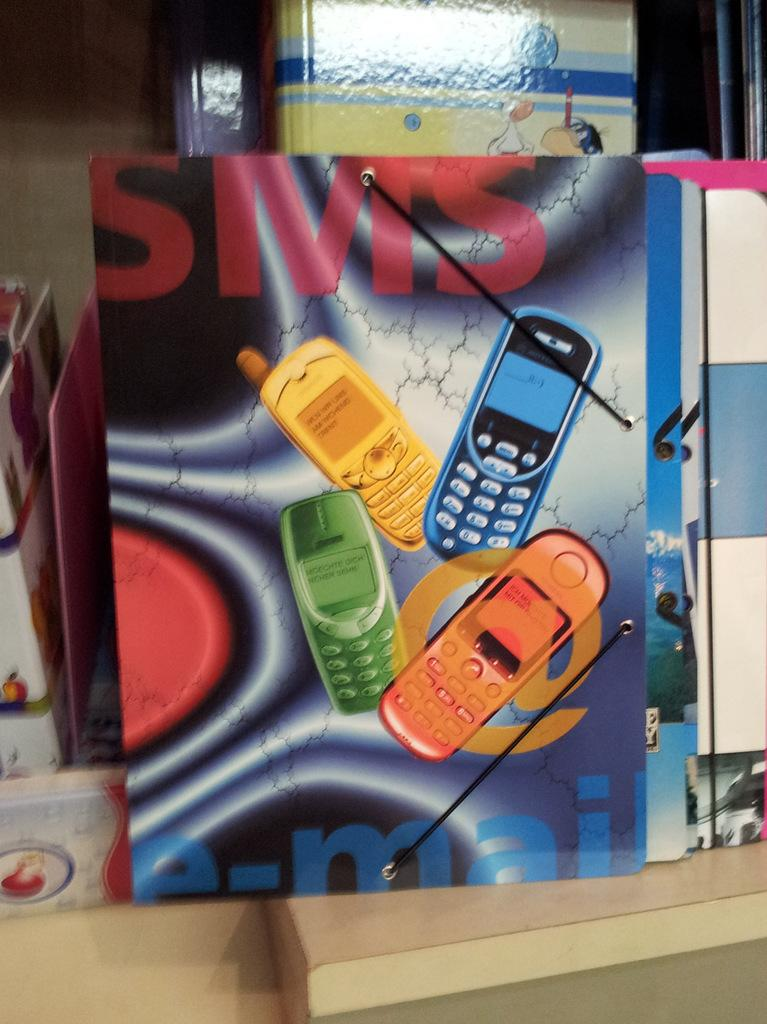<image>
Provide a brief description of the given image. SMS is written in bold red letters on top of the folder with multi-colored cell phones. 